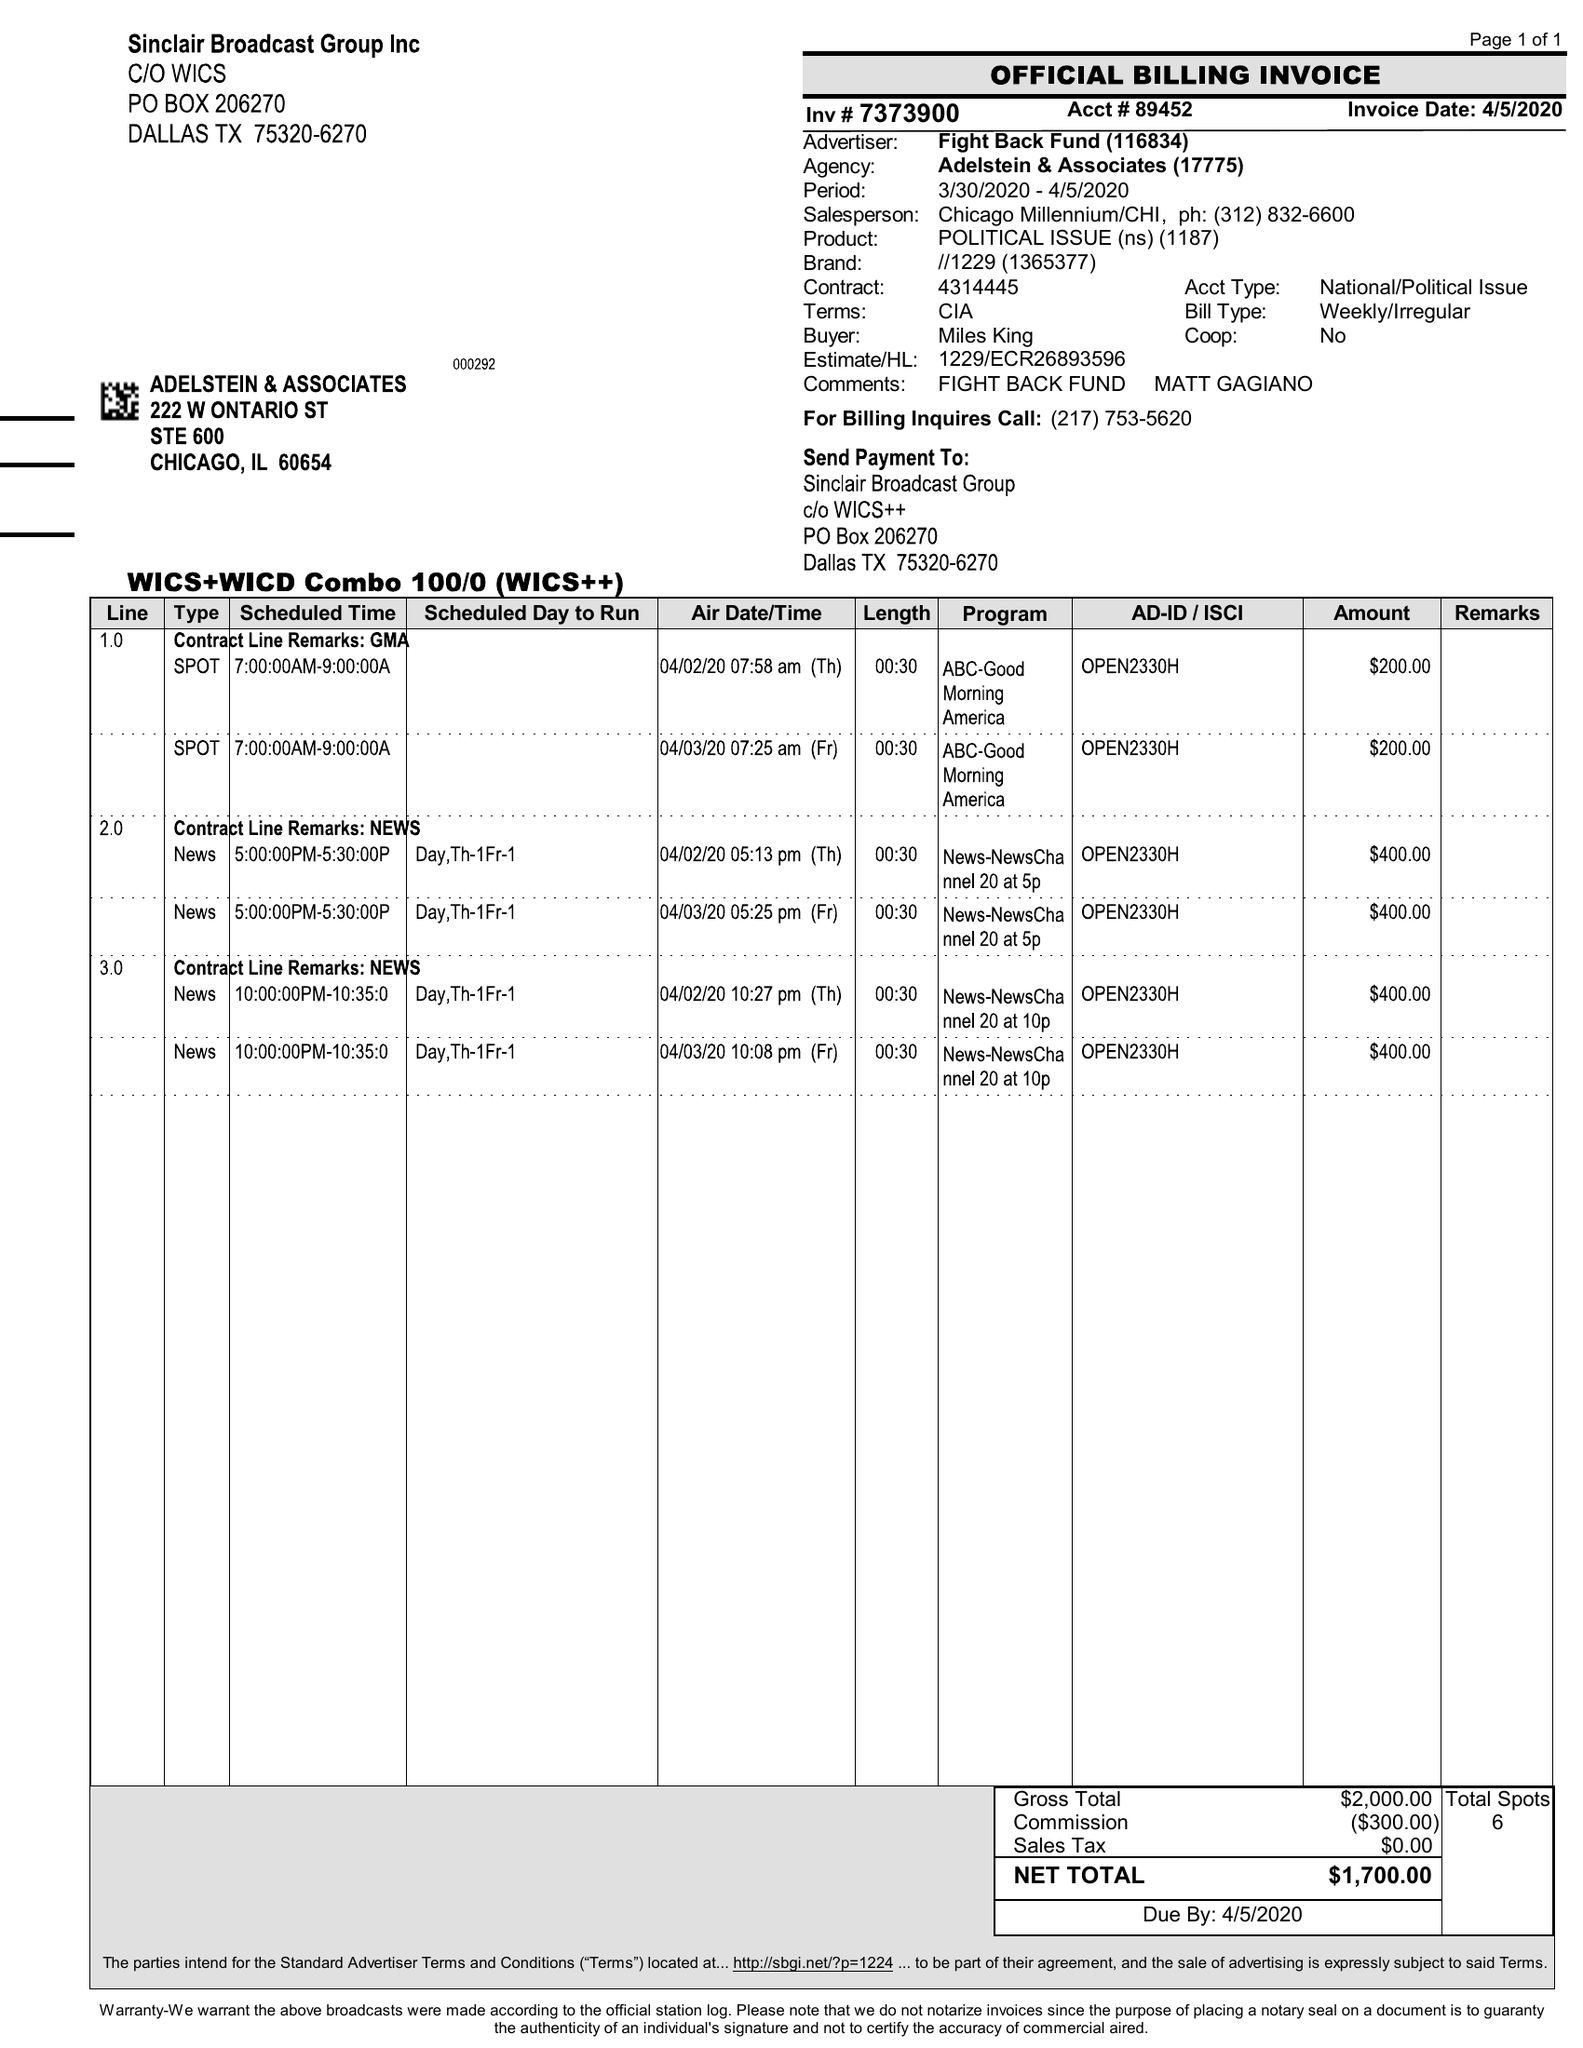What is the value for the advertiser?
Answer the question using a single word or phrase. FIGHT BACK FUND 